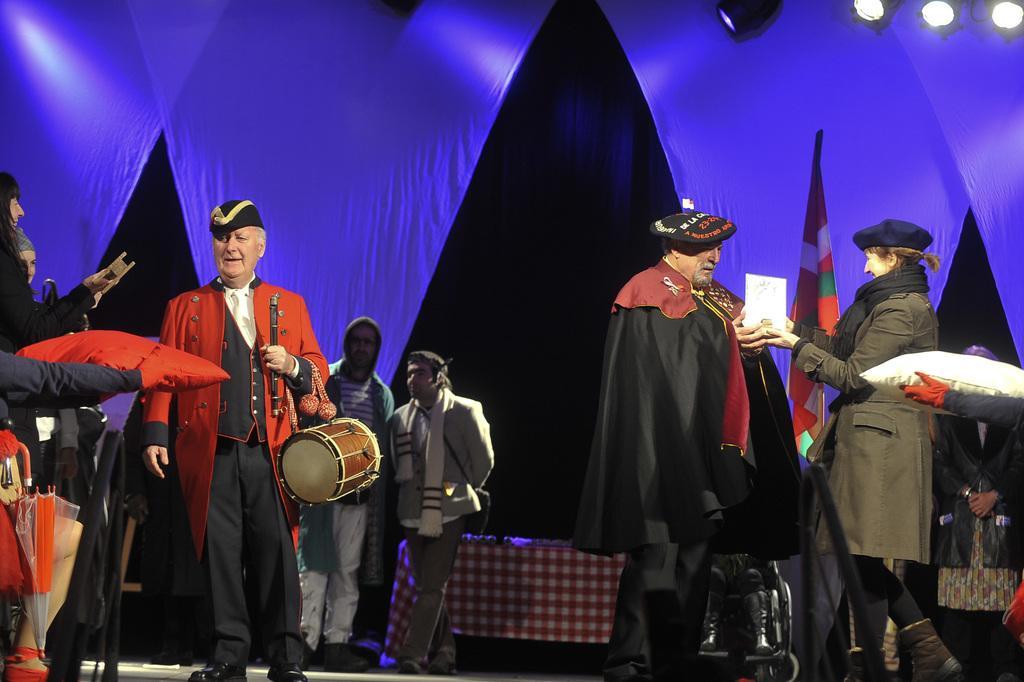Please provide a concise description of this image. In this image there are many people. On the right there is a woman she is smiling she is holding a paper. On the left there is a man he wear red jacket, trouser, cap and shoes he is holding a drum. In the background there are many people, lights, stage. 